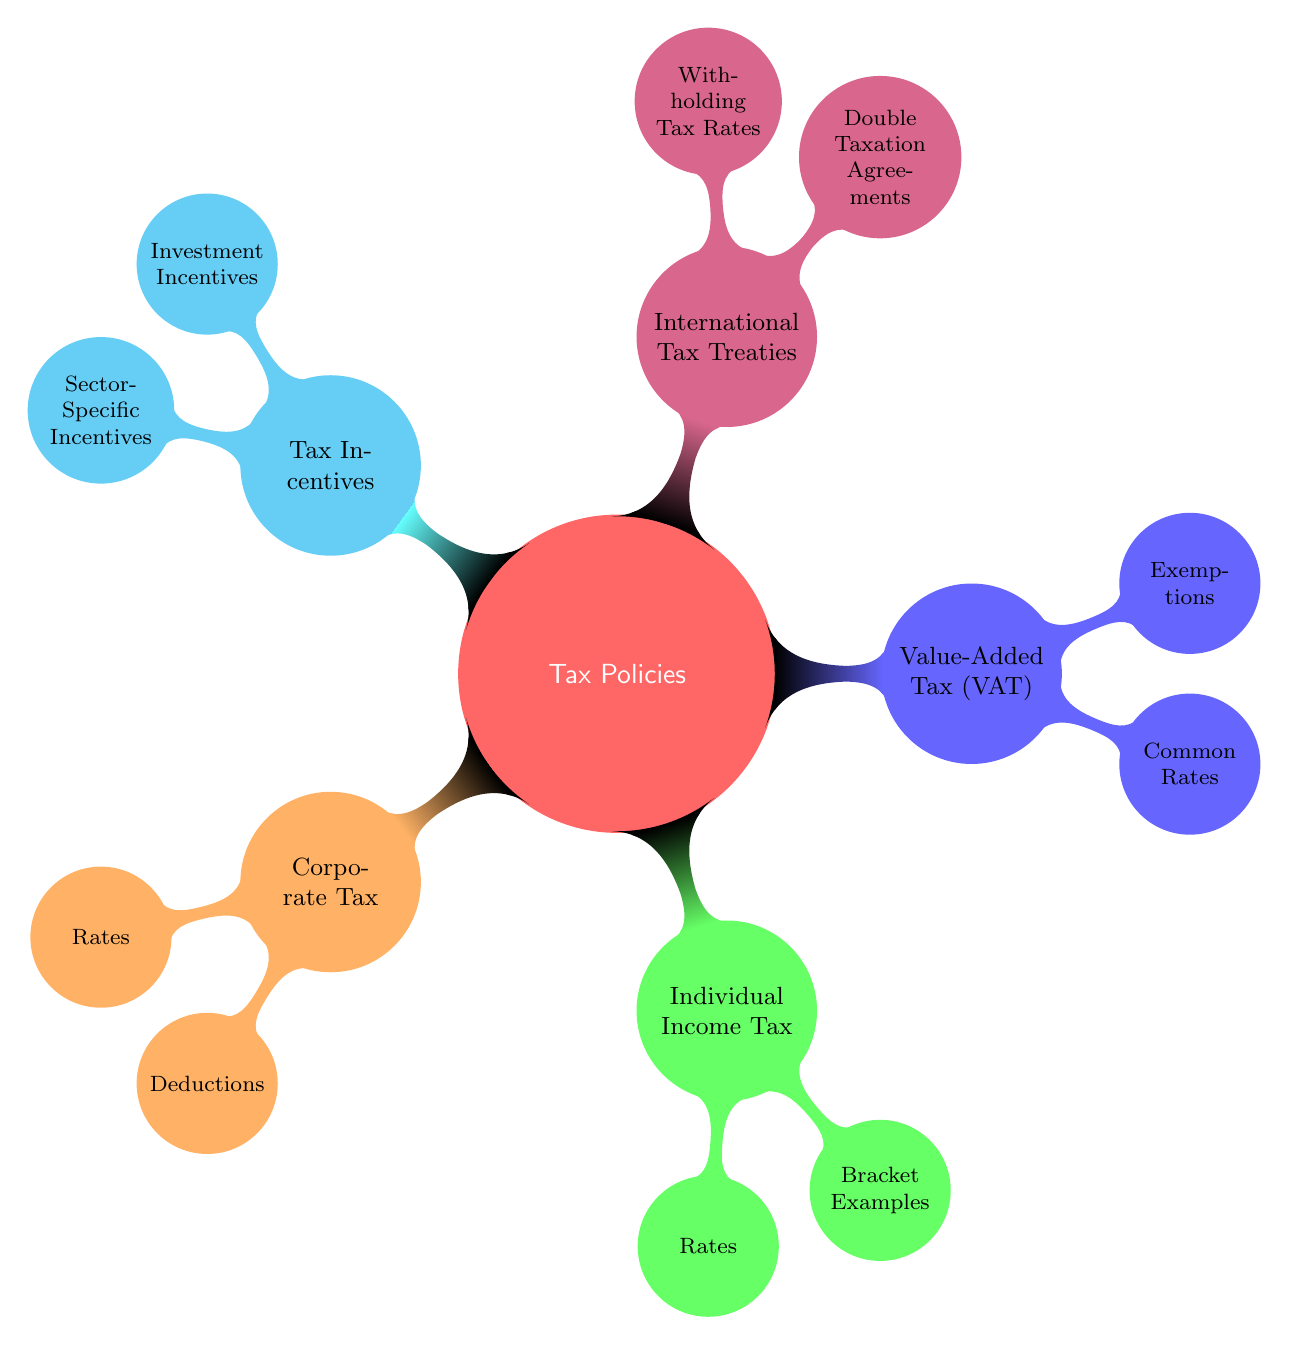What are the three main categories of tax policies? The diagram shows five main categories under "Tax Policies": Corporate Tax, Individual Income Tax, Value-Added Tax (VAT), International Tax Treaties, and Tax Incentives.
Answer: Corporate Tax, Individual Income Tax, Value-Added Tax (VAT) What is the rate of corporate tax in Germany? Under the "Corporate Tax" section, one of the nodes lists the rates for different countries, and Germany's rate is specified as 15%.
Answer: 15% What type of tax is characterized by progressive, flat, or regressive rates? The "Individual Income Tax" section identifies that it uses the terms progressive, flat, and regressive to describe its types.
Answer: Individual Income Tax How many types of exemptions are mentioned under Value-Added Tax (VAT)? The "Value-Added Tax (VAT)" section lists exemptions, and there are three specific exemptions shown: Food, Healthcare Services, and Education.
Answer: 3 What do double taxation agreements aim to address? The section "International Tax Treaties" contains double taxation agreements which are set up to prevent tax being paid in both countries for the same income.
Answer: Double Taxation Which incentives are provided under Tax Incentives? The "Tax Incentives" node specifies two categories: Investment Incentives and Sector-Specific Incentives, detailing that these are efforts to encourage specific types of investments.
Answer: Investment Incentives, Sector-Specific Incentives What is a common feature of the "Individual Income Tax" bracket examples listed? The brackets for the US, UK, and Singapore specify different percentage ranges for taxation, illustrating how individual income taxes vary significantly by region.
Answer: Percentage ranges What is the highest withholding tax rate for dividends listed under International Tax Treaties? Under "International Tax Treaties," the withholding tax rate for dividends is specified as 15%, which is noted as a fixed rate across the agreements.
Answer: 15% 